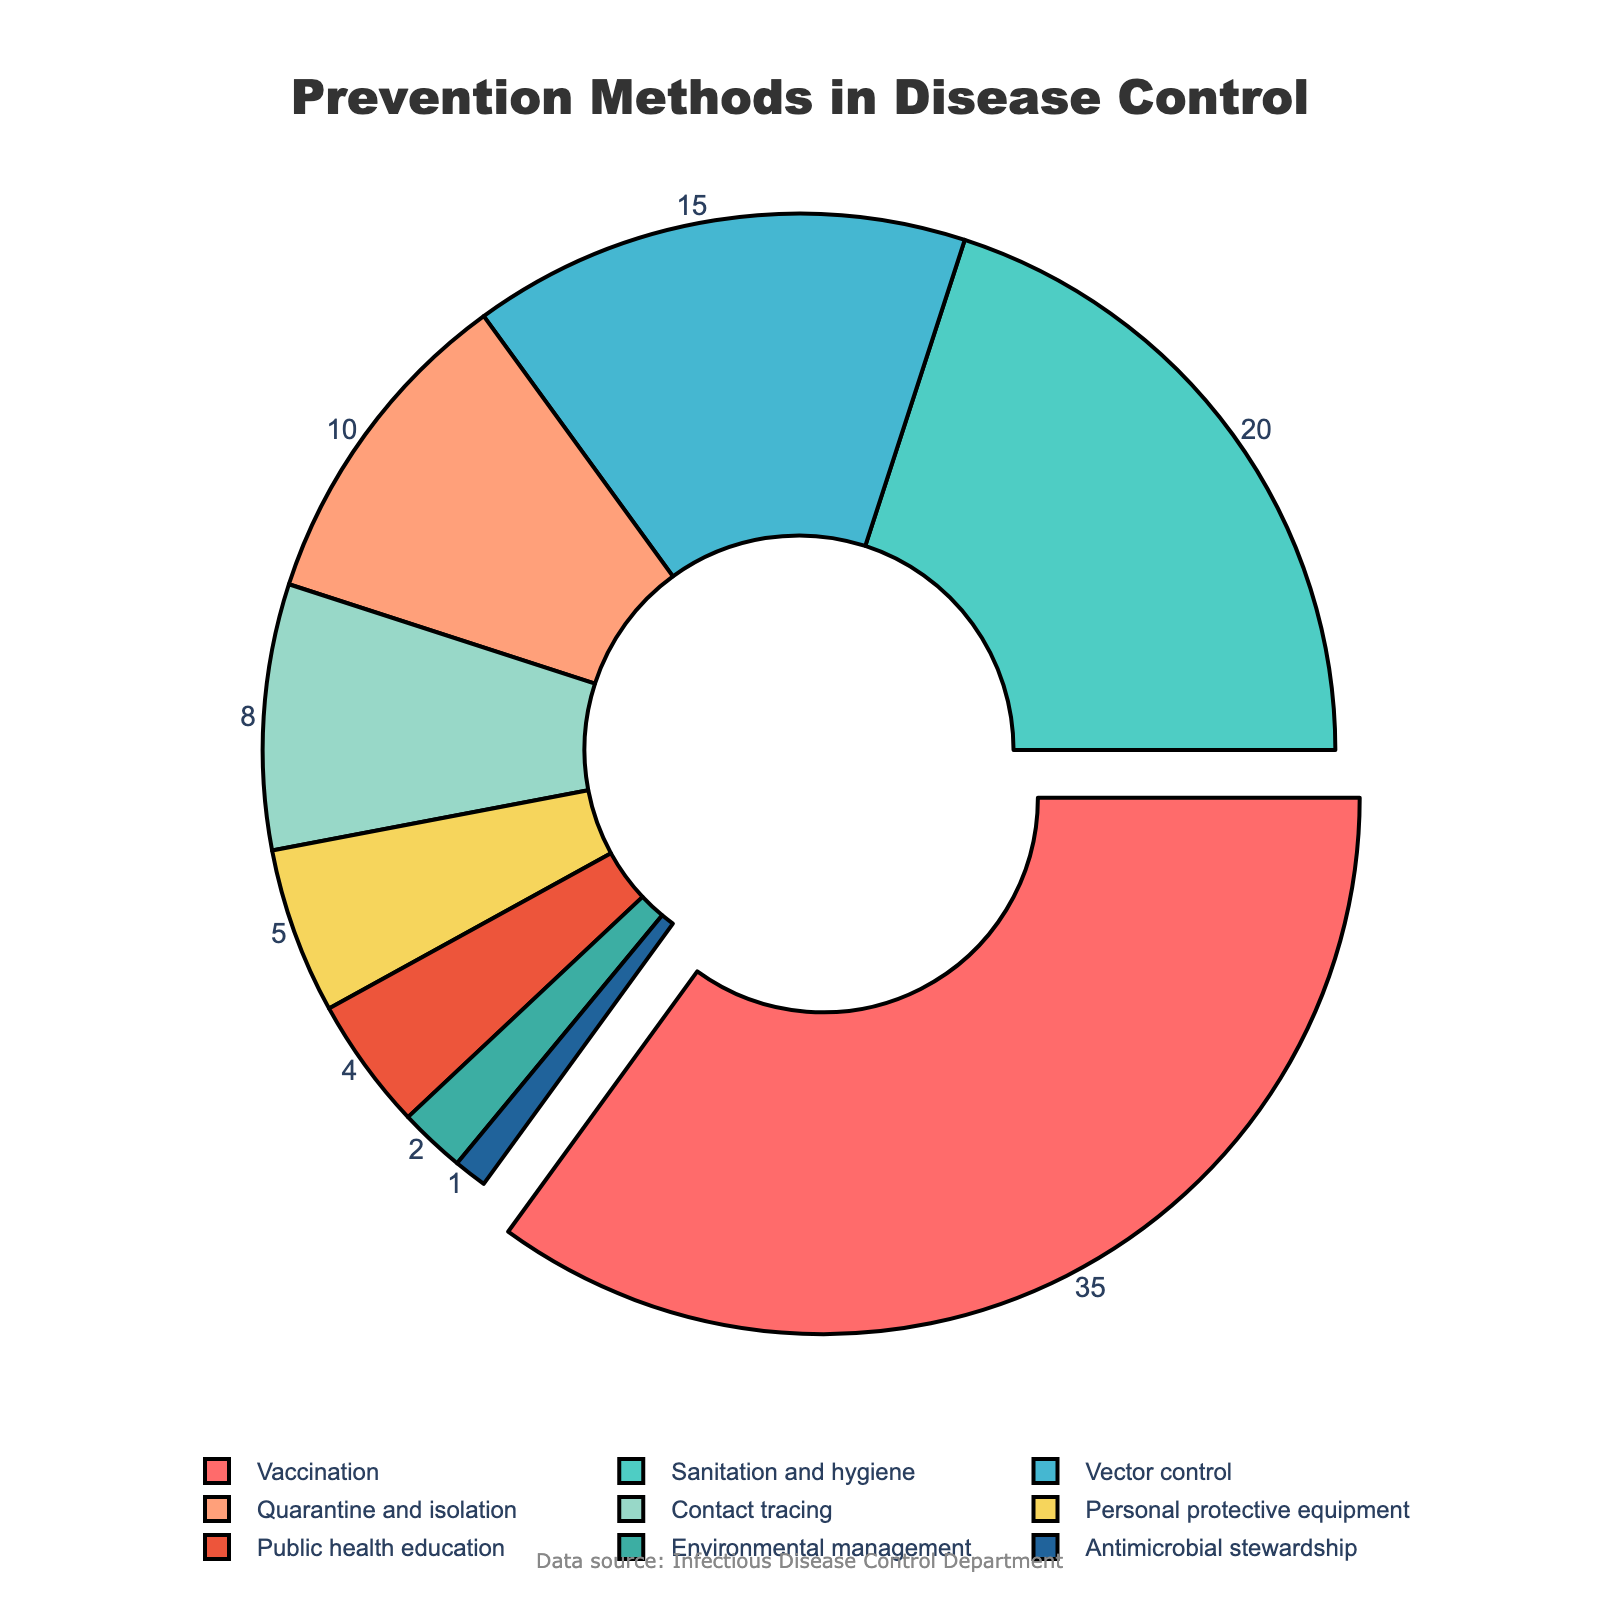Which prevention method has the highest percentage? The method with the highest percentage can be identified by finding the segment with the largest value in the chart. "Vaccination" has the highest percentage of 35%.
Answer: Vaccination What is the combined percentage of Sanitation and hygiene, Vector control, and Quarantine and isolation? Adding the percentages of these methods: 20% (Sanitation and hygiene) + 15% (Vector control) + 10% (Quarantine and isolation) = 45%.
Answer: 45% Which method occupies the smallest segment in the pie chart? By identifying the smallest value in the chart, "Antimicrobial stewardship" occupies the smallest segment with 1%.
Answer: Antimicrobial stewardship Are there more preventive measures that involve direct intervention (like Vaccination and Vector control) than indirect measures (like Public health education and Environmental management)? Count the direct intervention measures (Vaccination, Vector control, Personal protective equipment) which add up to 35% + 15% + 5% = 55%, and compare it with the indirect measures (Sanitation and hygiene, Public health education, Environmental management): 20% + 4% + 2% = 26%.
Answer: Yes How much larger is the percentage for Vaccination compared to Personal protective equipment? Subtract the percentage of Personal protective equipment (5%) from Vaccination (35%): 35% - 5% = 30%.
Answer: 30% What percentage of methods fall under 10% individually? List the methods under 10%: Quarantine and isolation (10%), Contact tracing (8%), Personal protective equipment (5%), Public health education (4%), Environmental management (2%), Antimicrobial stewardship (1%). Separately they are 10%, 8%, 5%, 4%, 2%, and 1%, so six methods.
Answer: Six What is the color used for "Vector control" in the chart? Observing the colors in the chart's legend, "Vector control" is displayed in a particular color, which is blue.
Answer: Blue How many prevention methods have a percentage of 10% or more? Count the segments representing methods with 10% or more: Vaccination (35%), Sanitation and hygiene (20%), Vector control (15%), Quarantine and isolation (10%), which totals to four methods.
Answer: Four 